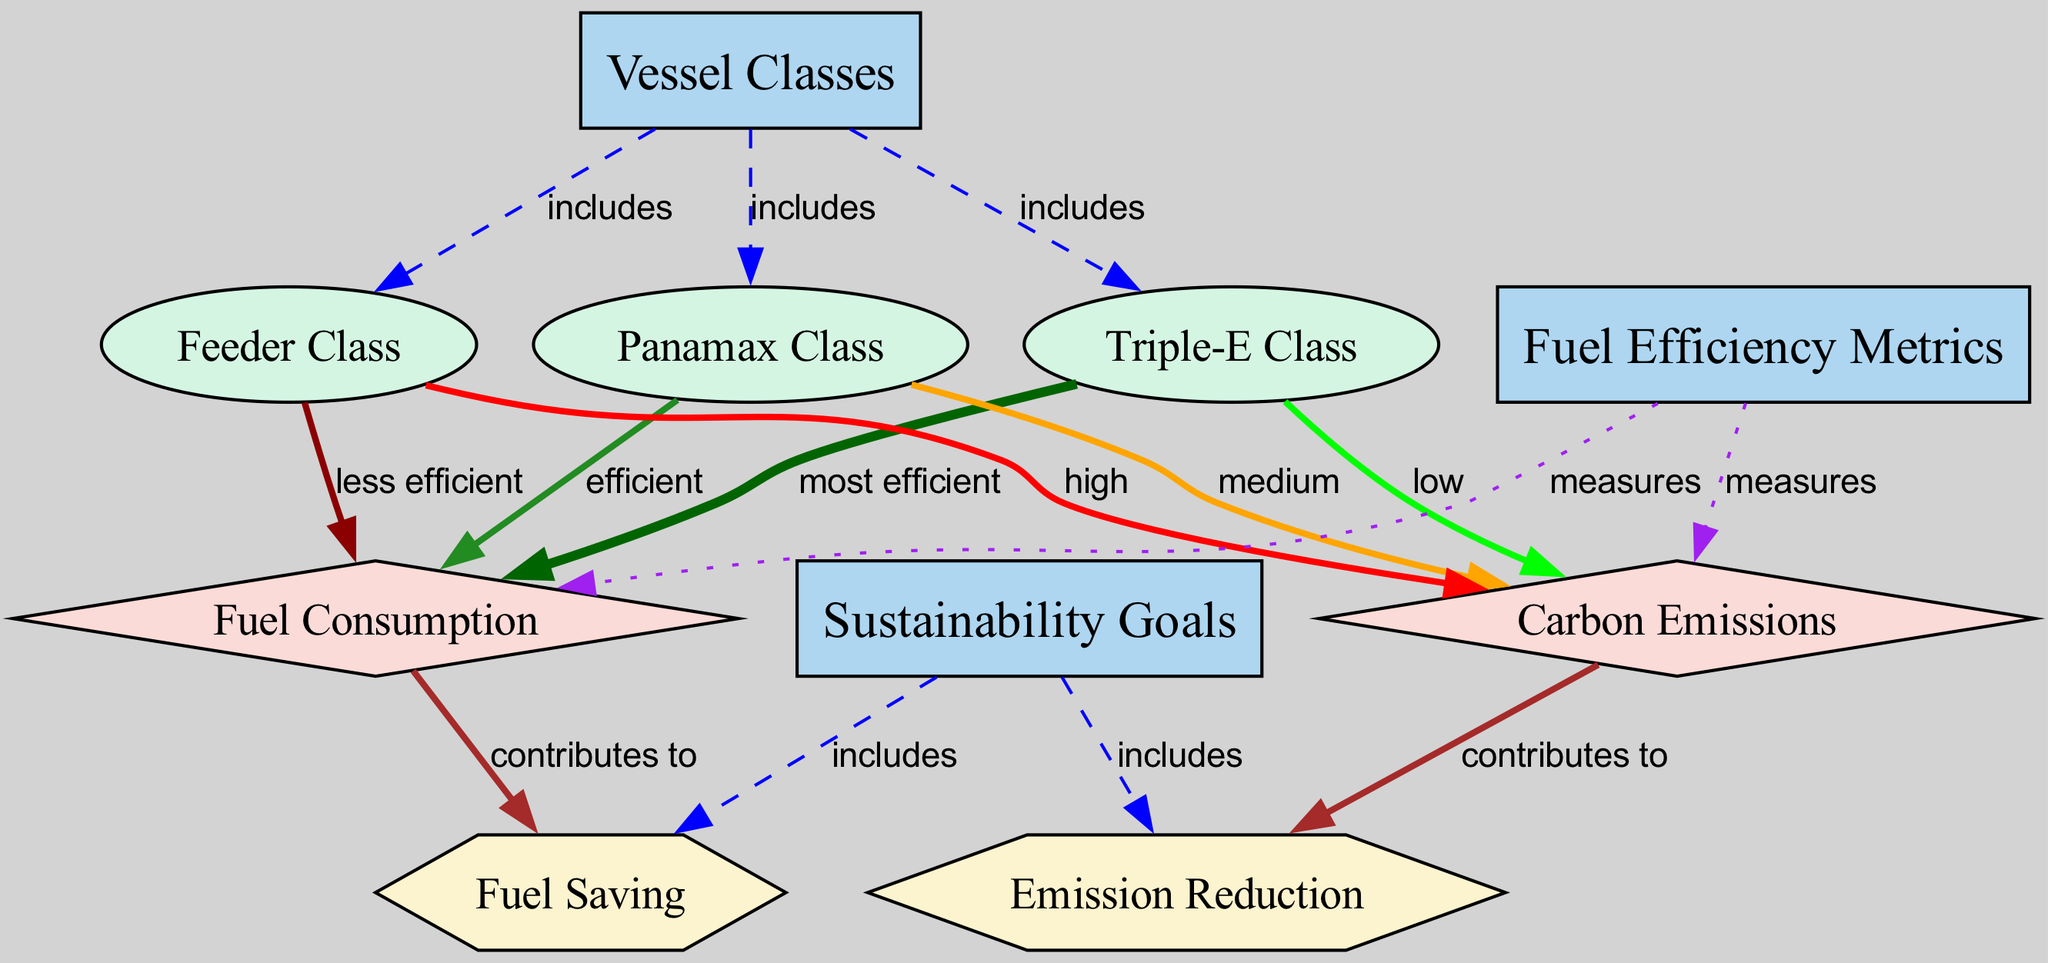What are the three vessel classes included in the diagram? The diagram lists three vessel classes: Triple-E Class, Panamax Class, and Feeder Class. This information is found by examining the "Vessel Classes" node, which has edges pointing to these three specific classes.
Answer: Triple-E Class, Panamax Class, Feeder Class Which vessel class has the highest carbon emissions? The diagram indicates that the Feeder Class has the highest carbon emissions. This can be determined by viewing the edges emanating from the Feeder Class, which shows it linked to "carbon emissions" with a "high" label.
Answer: Feeder Class What is the efficiency ranking of the Triple-E Class in terms of fuel consumption? According to the diagram, the Triple-E Class is labeled as "most efficient" concerning fuel consumption. This designation is visible through the edge that connects the Triple-E Class to the "fuel consumption" metric.
Answer: most efficient How many sustainability goals are included in the diagram? The diagram indicates that there are two sustainability goals: Emission Reduction and Fuel Saving. This information can be obtained from the "Sustainability Goals" node, which has edges pointing to both goals.
Answer: 2 What are the contributions of fuel consumption and carbon emissions to sustainability goals? The fuel consumption contributes to fuel saving, while the carbon emissions contribute to emission reduction. This can be established by tracing the edges from these metrics to their respective goals identified under "sustainability goals."
Answer: fuel saving, emission reduction Which vessel class is the least efficient in terms of fuel consumption? The diagram shows that the Feeder Class is categorized as "less efficient" regarding fuel consumption. This information is confirmed by the edge pointing from Feeder Class to the fuel consumption metric.
Answer: less efficient How does the Panamax Class rank in terms of carbon emissions? The Panamax Class is classified as having "medium" carbon emissions as shown in the diagram, represented by the edge connecting it to the carbon emissions metric with that specific label.
Answer: medium What type of relationship exists between fuel efficiency metrics and sustainability goals? The relationship is that fuel efficiency metrics measure both carbon emissions and fuel consumption, which in turn contribute to the sustainability goals of emission reduction and fuel saving. The connections illustrate a flow from fuel efficiency metrics to sustainability goals through these contributions.
Answer: measures, contributes to 